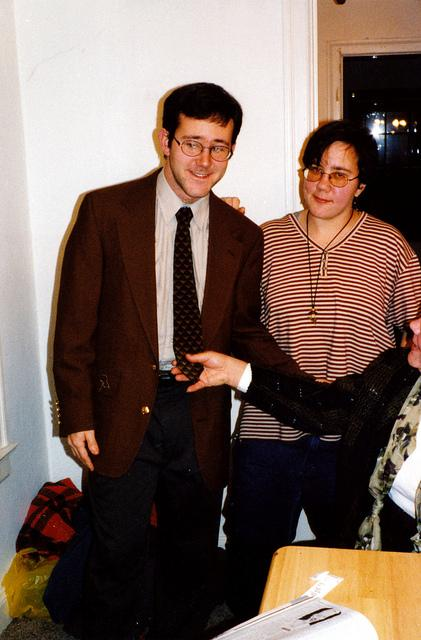What is sometimes substituted for the item the woman is holding? Please explain your reasoning. bow tie. Bowties can be subbed for ties. 